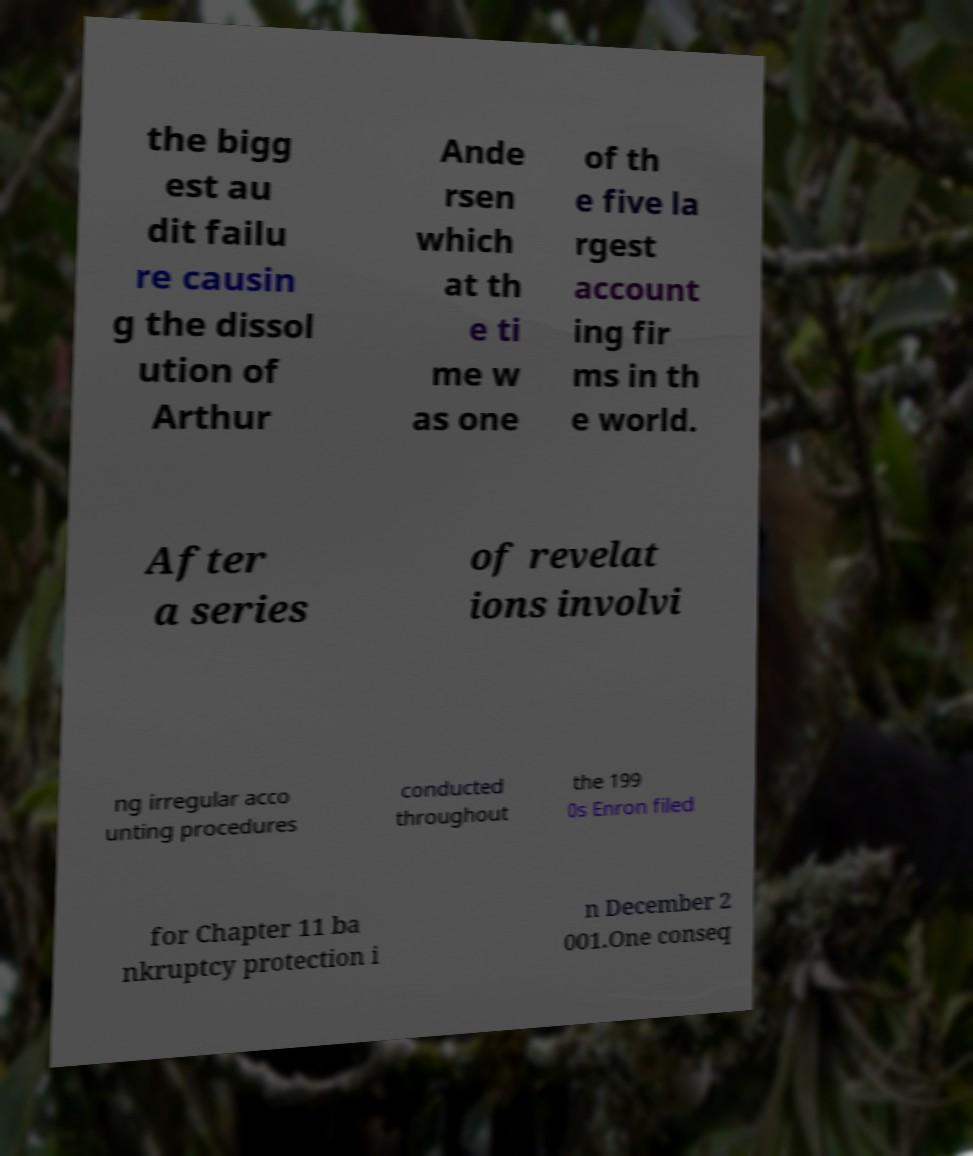Could you assist in decoding the text presented in this image and type it out clearly? the bigg est au dit failu re causin g the dissol ution of Arthur Ande rsen which at th e ti me w as one of th e five la rgest account ing fir ms in th e world. After a series of revelat ions involvi ng irregular acco unting procedures conducted throughout the 199 0s Enron filed for Chapter 11 ba nkruptcy protection i n December 2 001.One conseq 